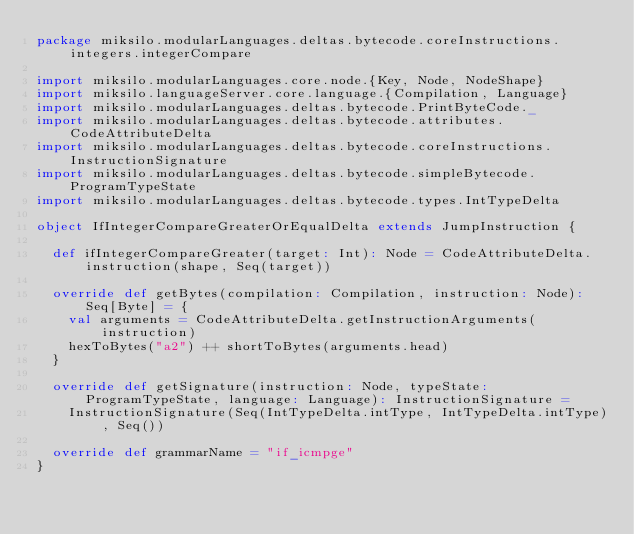Convert code to text. <code><loc_0><loc_0><loc_500><loc_500><_Scala_>package miksilo.modularLanguages.deltas.bytecode.coreInstructions.integers.integerCompare

import miksilo.modularLanguages.core.node.{Key, Node, NodeShape}
import miksilo.languageServer.core.language.{Compilation, Language}
import miksilo.modularLanguages.deltas.bytecode.PrintByteCode._
import miksilo.modularLanguages.deltas.bytecode.attributes.CodeAttributeDelta
import miksilo.modularLanguages.deltas.bytecode.coreInstructions.InstructionSignature
import miksilo.modularLanguages.deltas.bytecode.simpleBytecode.ProgramTypeState
import miksilo.modularLanguages.deltas.bytecode.types.IntTypeDelta

object IfIntegerCompareGreaterOrEqualDelta extends JumpInstruction {

  def ifIntegerCompareGreater(target: Int): Node = CodeAttributeDelta.instruction(shape, Seq(target))

  override def getBytes(compilation: Compilation, instruction: Node): Seq[Byte] = {
    val arguments = CodeAttributeDelta.getInstructionArguments(instruction)
    hexToBytes("a2") ++ shortToBytes(arguments.head)
  }

  override def getSignature(instruction: Node, typeState: ProgramTypeState, language: Language): InstructionSignature =
    InstructionSignature(Seq(IntTypeDelta.intType, IntTypeDelta.intType), Seq())

  override def grammarName = "if_icmpge"
}
</code> 